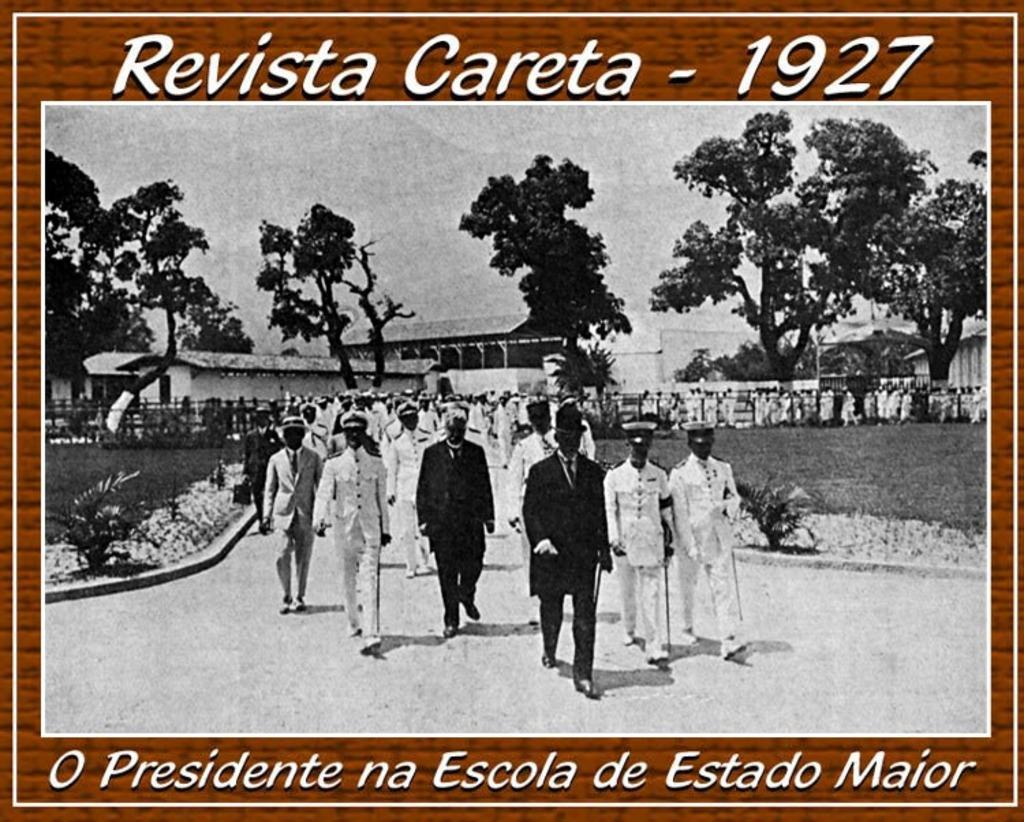<image>
Create a compact narrative representing the image presented. Revista Careta - 1927 shows many men walking out in their uniforms 